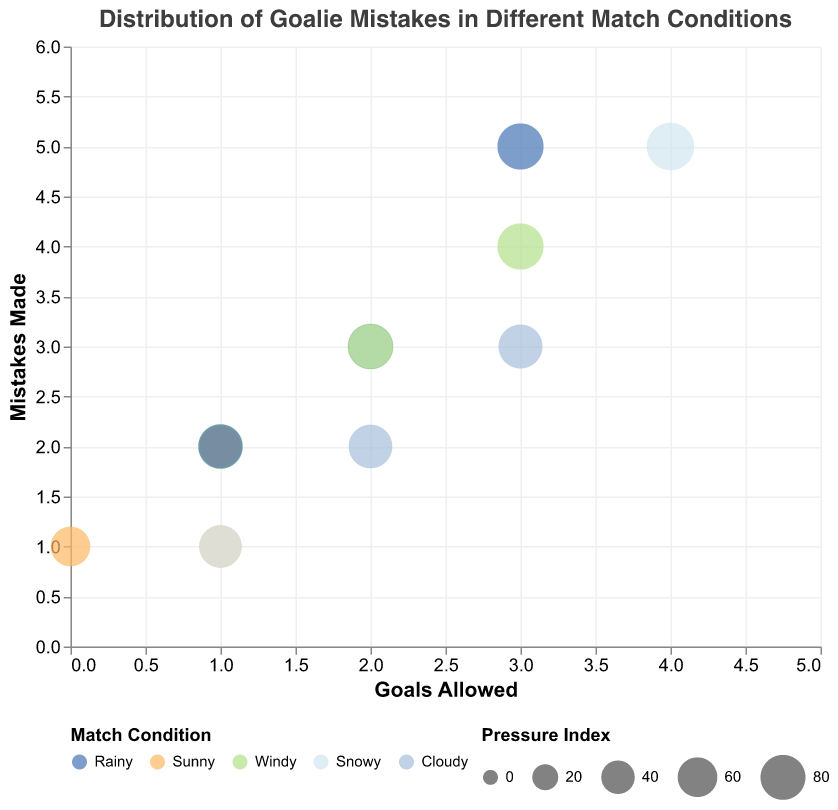What's the title of the chart? The title of the chart is displayed at the top center, indicating what the chart represents.
Answer: Distribution of Goalie Mistakes in Different Match Conditions What does the x-axis represent? The x-axis label is at the bottom of the chart, indicating what measure it represents.
Answer: Goals Allowed What does the y-axis represent? The y-axis label is at the left side of the chart, indicating what measure it represents.
Answer: Mistakes Made Which match condition has the goalie with the highest pressure index? By examining the size of the bubbles, the largest bubble represents the highest pressure index, which corresponds to the match condition. The largest bubble is under snowy conditions for Ethan Williams, with a pressure index of 90.
Answer: Snowy How many data points are there in the chart? Count the number of bubbles in the chart, each representing a data point.
Answer: 14 Under which conditions did the goalie make the most mistakes? Look at the y-axis for the highest value in the Mistakes Made and see the corresponding match condition by color and tooltip. The highest number of mistakes is 5, which occurred in snowy and rainy conditions for Ethan Williams and Chris Dermott.
Answer: Snowy, Rainy Which goalie allows the least goals under Sunny conditions? By analyzing the bubbles that correspond to Sunny conditions, check the Goals Allowed value. The least goals allowed under Sunny conditions are zero, achieved by Alex Johnson.
Answer: Alex Johnson Compare the mistakes made by goalies under Rainy and Cloudy conditions. Which condition resulted in more mistakes on average? Calculate the average mistakes for both conditions. For Rainy: (3+5+2)/3 = 3.33. For Cloudy: (2+3)/2 = 2.5. Therefore, Rainy conditions result in more mistakes on average.
Answer: Rainy What is the total number of goals allowed under Windy conditions? Sum the Goals Allowed values for all Windy conditions. The values are 3, 1, and 2, leading to a total of 3+1+2 = 6.
Answer: 6 Which pressure index is associated with the smallest bubble and what are its match conditions? The smallest bubbles correspond to the lowest pressure indices seen on the legend. By examining, the smallest bubble has a pressure index of 60, under Sunny conditions for Alex Johnson.
Answer: 60, Sunny 